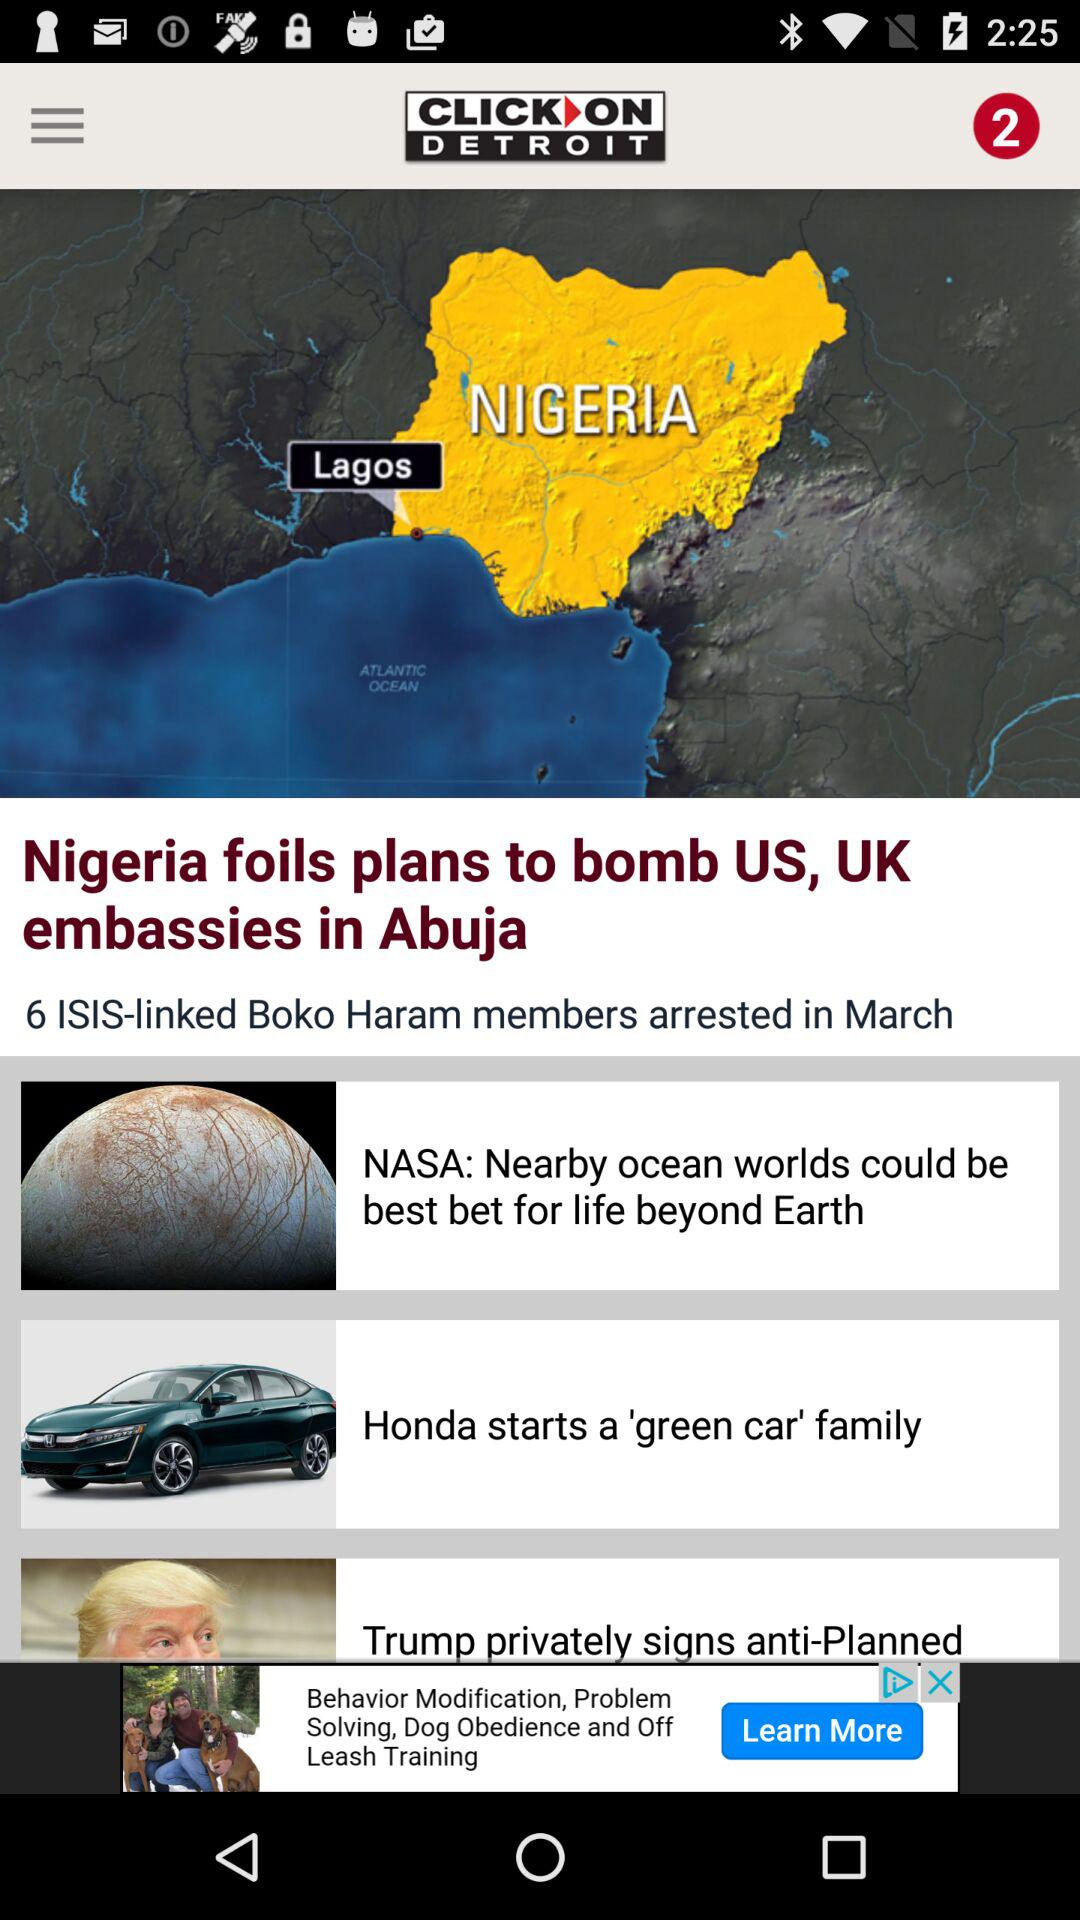Who foiled plans to bomb the US and UK embassies in Abuja? Plans to bomb the US and UK embassies in Abuja were foiled by Nigeria. 